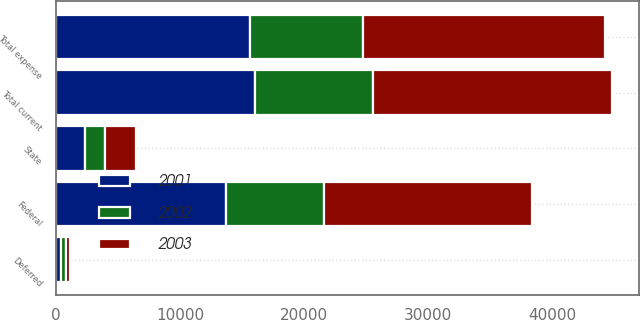Convert chart to OTSL. <chart><loc_0><loc_0><loc_500><loc_500><stacked_bar_chart><ecel><fcel>Federal<fcel>State<fcel>Total current<fcel>Deferred<fcel>Total expense<nl><fcel>2003<fcel>16776<fcel>2464<fcel>19240<fcel>264<fcel>19504<nl><fcel>2001<fcel>13661<fcel>2338<fcel>15999<fcel>368<fcel>15631<nl><fcel>2002<fcel>7952<fcel>1624<fcel>9576<fcel>445<fcel>9131<nl></chart> 